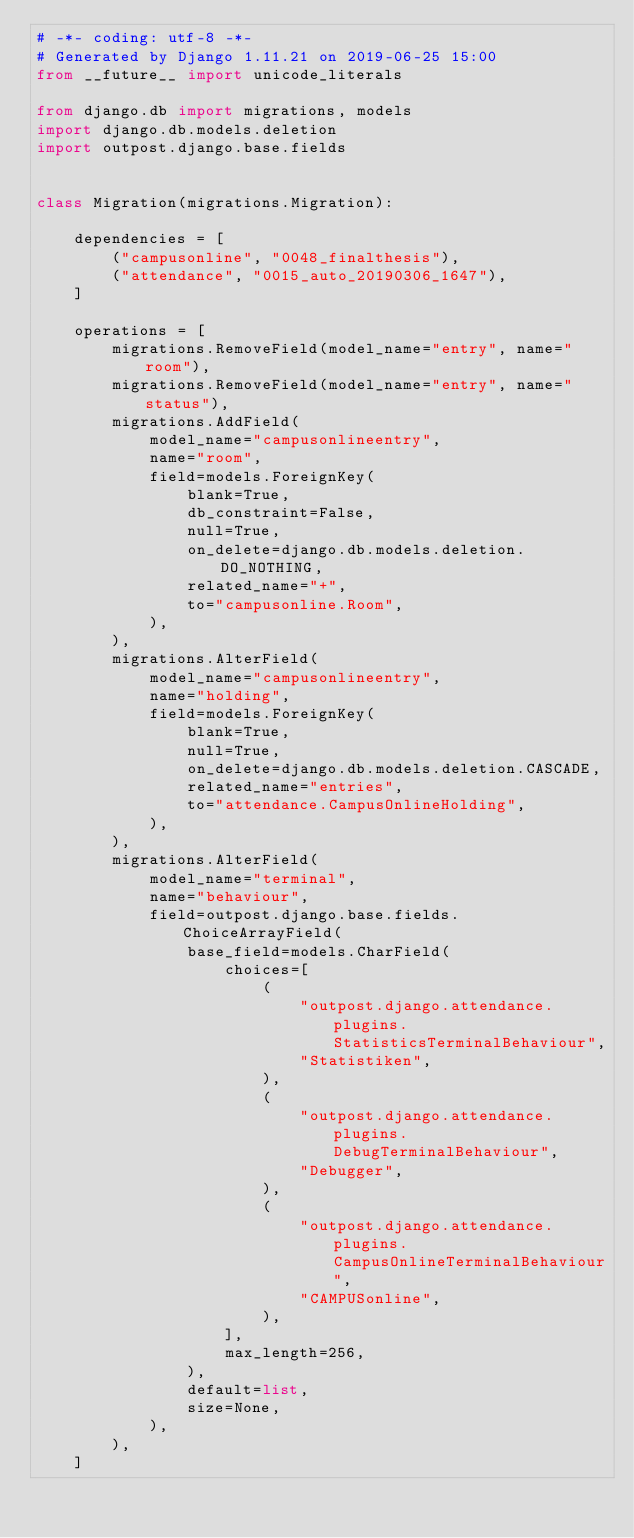Convert code to text. <code><loc_0><loc_0><loc_500><loc_500><_Python_># -*- coding: utf-8 -*-
# Generated by Django 1.11.21 on 2019-06-25 15:00
from __future__ import unicode_literals

from django.db import migrations, models
import django.db.models.deletion
import outpost.django.base.fields


class Migration(migrations.Migration):

    dependencies = [
        ("campusonline", "0048_finalthesis"),
        ("attendance", "0015_auto_20190306_1647"),
    ]

    operations = [
        migrations.RemoveField(model_name="entry", name="room"),
        migrations.RemoveField(model_name="entry", name="status"),
        migrations.AddField(
            model_name="campusonlineentry",
            name="room",
            field=models.ForeignKey(
                blank=True,
                db_constraint=False,
                null=True,
                on_delete=django.db.models.deletion.DO_NOTHING,
                related_name="+",
                to="campusonline.Room",
            ),
        ),
        migrations.AlterField(
            model_name="campusonlineentry",
            name="holding",
            field=models.ForeignKey(
                blank=True,
                null=True,
                on_delete=django.db.models.deletion.CASCADE,
                related_name="entries",
                to="attendance.CampusOnlineHolding",
            ),
        ),
        migrations.AlterField(
            model_name="terminal",
            name="behaviour",
            field=outpost.django.base.fields.ChoiceArrayField(
                base_field=models.CharField(
                    choices=[
                        (
                            "outpost.django.attendance.plugins.StatisticsTerminalBehaviour",
                            "Statistiken",
                        ),
                        (
                            "outpost.django.attendance.plugins.DebugTerminalBehaviour",
                            "Debugger",
                        ),
                        (
                            "outpost.django.attendance.plugins.CampusOnlineTerminalBehaviour",
                            "CAMPUSonline",
                        ),
                    ],
                    max_length=256,
                ),
                default=list,
                size=None,
            ),
        ),
    ]
</code> 